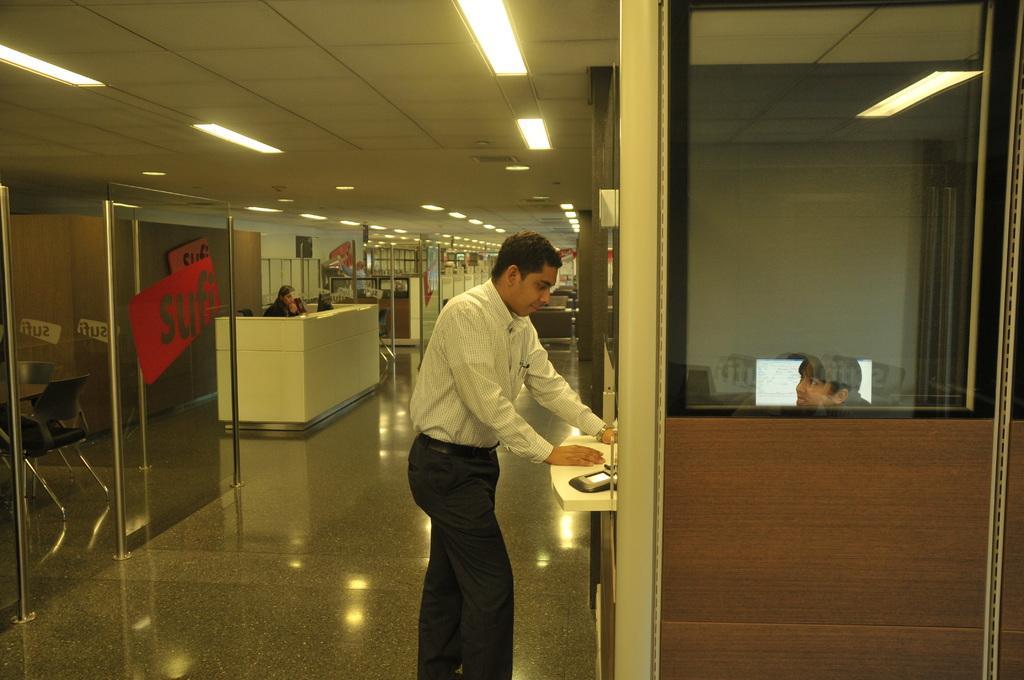In one or two sentences, can you explain what this image depicts? In this image we can see a group of people. One person is standing on the floor. On the right side of the image we can see a device is placed on the table and a person is sitting in a cabin and a scream. In the background, we can see a group of chairs and table placed on the floor, group of poles and lights. 